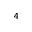Convert formula to latex. <formula><loc_0><loc_0><loc_500><loc_500>_ { 4 }</formula> 